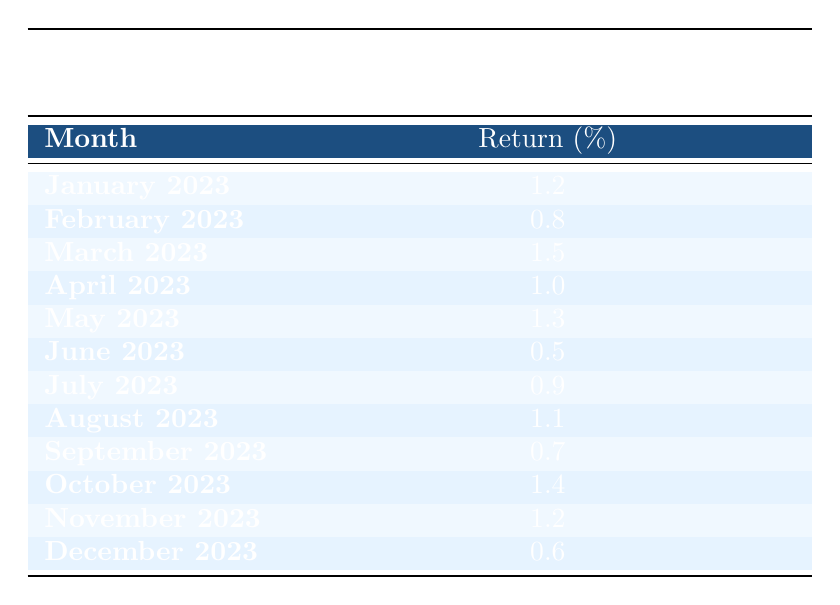What was the highest monthly return for the fund in 2023? The table shows the monthly returns for each month in 2023. Scanning through the returns, March 2023 has the highest return percentage of 1.5%.
Answer: 1.5% What was the average monthly return for this fund over the last year? To find the average, sum all the monthly returns: 1.2 + 0.8 + 1.5 + 1.0 + 1.3 + 0.5 + 0.9 + 1.1 + 0.7 + 1.4 + 1.2 + 0.6 = 12.2%. There are 12 months, so the average return is 12.2 / 12 = 1.01667%, which rounds to about 1.02%.
Answer: 1.02% Did the fund have a month with a return below 1%? Looking at the table, the months of February (0.8%), June (0.5%), and September (0.7%) all show returns below 1%. Therefore, the statement is true.
Answer: Yes Which month had the lowest return, and what was it? Scanning the table, June 2023 has the lowest return of 0.5%.
Answer: June 2023, 0.5% How many months had returns of 1% or higher? Checking the table, the months with returns of 1% or higher are January (1.2), March (1.5), April (1.0), May (1.3), August (1.1), October (1.4), and November (1.2). That gives a total of 7 months.
Answer: 7 